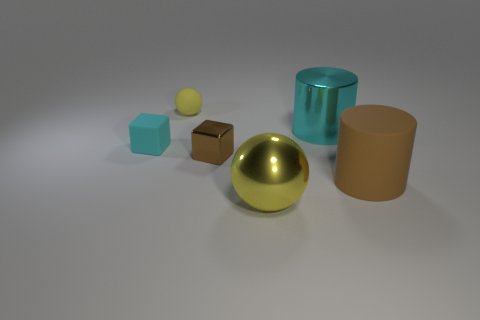What is the size of the other ball that is the same color as the big ball?
Make the answer very short. Small. There is a small thing on the right side of the small yellow matte thing; what is its material?
Offer a very short reply. Metal. There is a shiny sphere that is the same size as the metallic cylinder; what color is it?
Your answer should be compact. Yellow. How many other objects are there of the same shape as the big cyan thing?
Offer a terse response. 1. Is the size of the brown metallic cube the same as the yellow shiny object?
Offer a terse response. No. Is the number of objects on the right side of the small yellow matte sphere greater than the number of matte cylinders left of the big cyan cylinder?
Your answer should be very brief. Yes. How many other objects are there of the same size as the matte cylinder?
Keep it short and to the point. 2. Do the large object in front of the big brown rubber object and the rubber cylinder have the same color?
Offer a terse response. No. Are there more big yellow shiny objects in front of the big cyan object than matte spheres?
Your answer should be very brief. No. Is there anything else that has the same color as the metal cylinder?
Provide a succinct answer. Yes. 